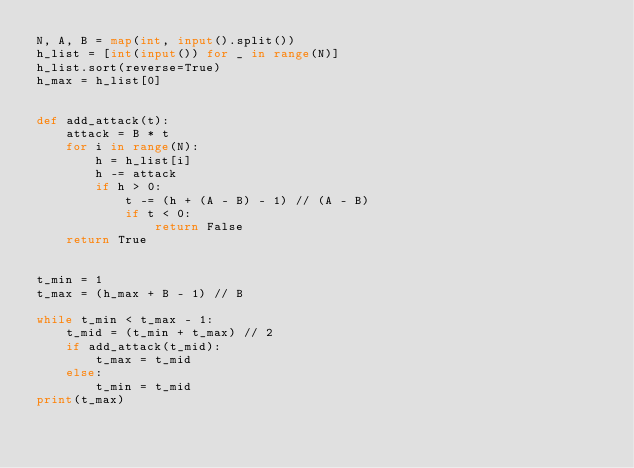Convert code to text. <code><loc_0><loc_0><loc_500><loc_500><_Python_>N, A, B = map(int, input().split())
h_list = [int(input()) for _ in range(N)]
h_list.sort(reverse=True)
h_max = h_list[0]


def add_attack(t):
    attack = B * t
    for i in range(N):
        h = h_list[i]
        h -= attack
        if h > 0:
            t -= (h + (A - B) - 1) // (A - B)
            if t < 0:
                return False
    return True


t_min = 1
t_max = (h_max + B - 1) // B

while t_min < t_max - 1:
    t_mid = (t_min + t_max) // 2
    if add_attack(t_mid):
        t_max = t_mid
    else:
        t_min = t_mid
print(t_max)
</code> 